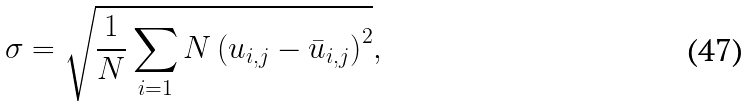Convert formula to latex. <formula><loc_0><loc_0><loc_500><loc_500>\sigma = \sqrt { \frac { 1 } { N } \sum _ { i = 1 } { N } \left ( u _ { i , j } - \bar { u } _ { i , j } \right ) ^ { 2 } } ,</formula> 